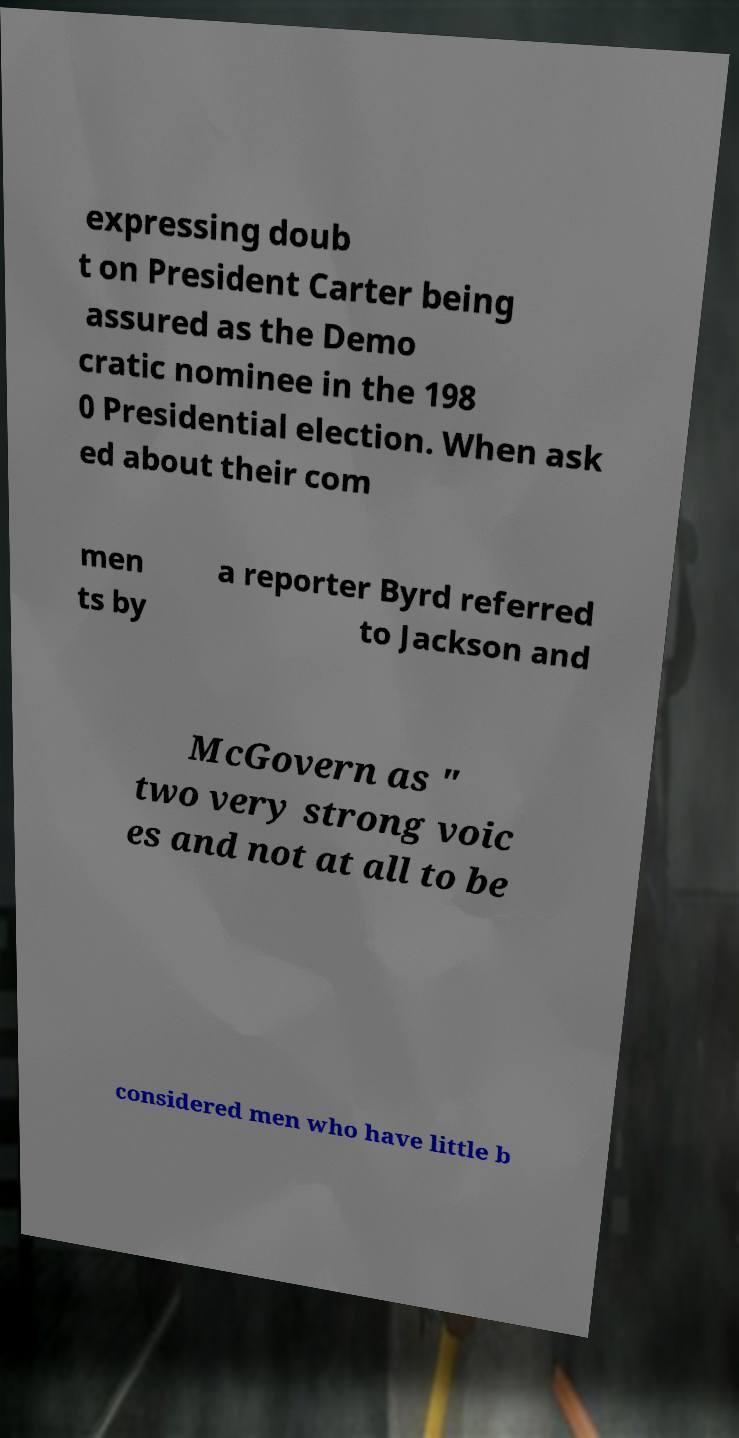Please read and relay the text visible in this image. What does it say? expressing doub t on President Carter being assured as the Demo cratic nominee in the 198 0 Presidential election. When ask ed about their com men ts by a reporter Byrd referred to Jackson and McGovern as " two very strong voic es and not at all to be considered men who have little b 